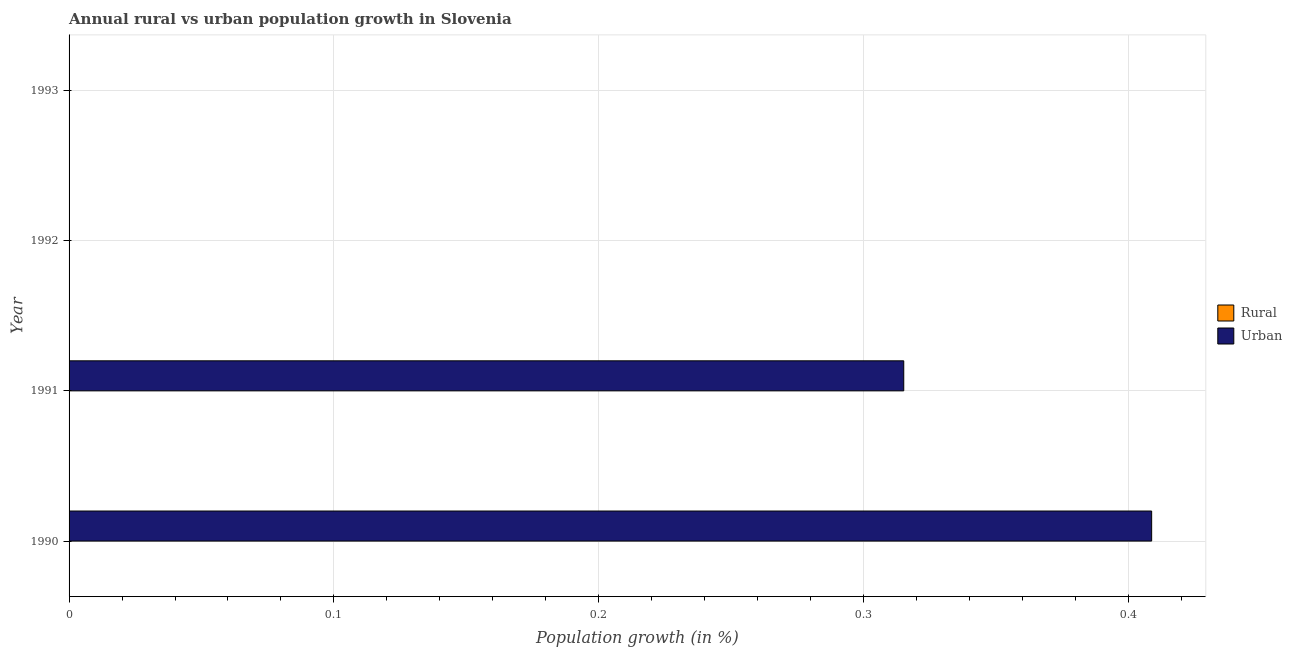How many different coloured bars are there?
Provide a succinct answer. 1. Are the number of bars per tick equal to the number of legend labels?
Provide a succinct answer. No. Are the number of bars on each tick of the Y-axis equal?
Provide a short and direct response. No. What is the rural population growth in 1990?
Give a very brief answer. 0. Across all years, what is the maximum urban population growth?
Provide a succinct answer. 0.41. In which year was the urban population growth maximum?
Your answer should be very brief. 1990. What is the total urban population growth in the graph?
Your answer should be compact. 0.72. What is the difference between the urban population growth in 1992 and the rural population growth in 1990?
Ensure brevity in your answer.  0. In how many years, is the rural population growth greater than 0.2 %?
Your answer should be compact. 0. What is the difference between the highest and the lowest urban population growth?
Provide a short and direct response. 0.41. In how many years, is the rural population growth greater than the average rural population growth taken over all years?
Provide a short and direct response. 0. What is the difference between two consecutive major ticks on the X-axis?
Provide a succinct answer. 0.1. Are the values on the major ticks of X-axis written in scientific E-notation?
Ensure brevity in your answer.  No. Does the graph contain grids?
Provide a short and direct response. Yes. What is the title of the graph?
Your answer should be very brief. Annual rural vs urban population growth in Slovenia. Does "Travel services" appear as one of the legend labels in the graph?
Make the answer very short. No. What is the label or title of the X-axis?
Make the answer very short. Population growth (in %). What is the Population growth (in %) in Urban  in 1990?
Your answer should be compact. 0.41. What is the Population growth (in %) of Rural in 1991?
Your answer should be very brief. 0. What is the Population growth (in %) of Urban  in 1991?
Make the answer very short. 0.32. What is the Population growth (in %) in Rural in 1992?
Keep it short and to the point. 0. Across all years, what is the maximum Population growth (in %) in Urban ?
Your answer should be very brief. 0.41. Across all years, what is the minimum Population growth (in %) in Urban ?
Give a very brief answer. 0. What is the total Population growth (in %) in Urban  in the graph?
Your answer should be compact. 0.72. What is the difference between the Population growth (in %) in Urban  in 1990 and that in 1991?
Offer a terse response. 0.09. What is the average Population growth (in %) of Rural per year?
Provide a succinct answer. 0. What is the average Population growth (in %) in Urban  per year?
Your answer should be compact. 0.18. What is the ratio of the Population growth (in %) of Urban  in 1990 to that in 1991?
Ensure brevity in your answer.  1.3. What is the difference between the highest and the lowest Population growth (in %) of Urban ?
Give a very brief answer. 0.41. 